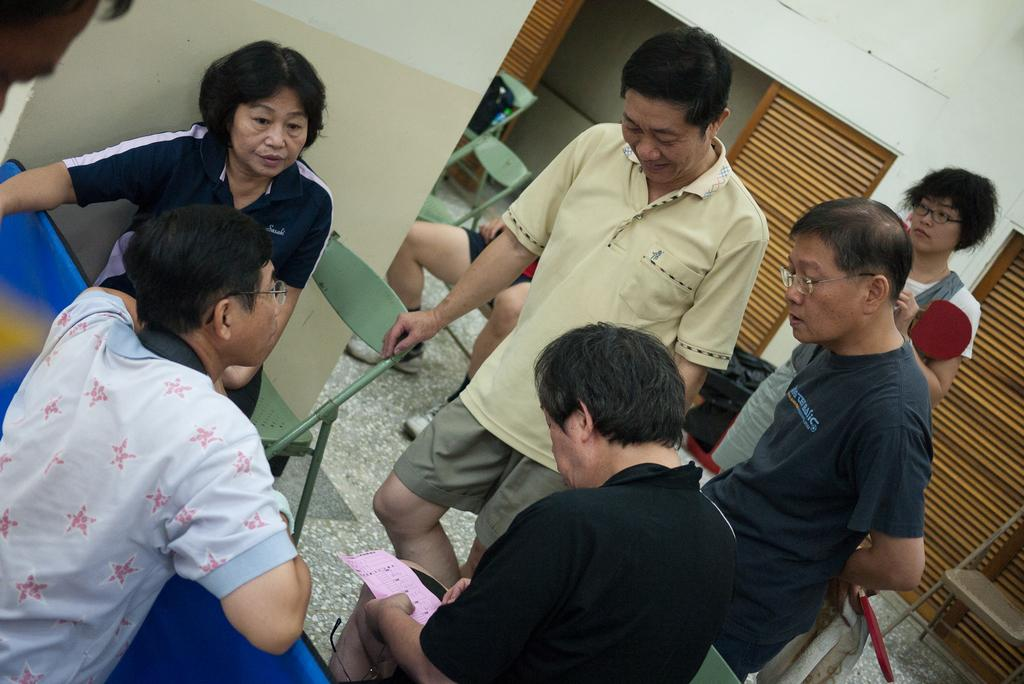Who or what can be seen in the image? There are people in the image. What are the people sitting on in the image? There are chairs in the image. What can be seen beneath the people and chairs? The ground is visible in the image. What is behind the people in the image? There is a wall in the image. What material is visible in the image? There is wood visible in the image. What color are some of the objects in the image? There are black colored objects in the image. What type of nose can be seen on the brother in the image? There is no brother or nose present in the image. How many quarters are visible on the wall in the image? There are no quarters visible on the wall in the image. 